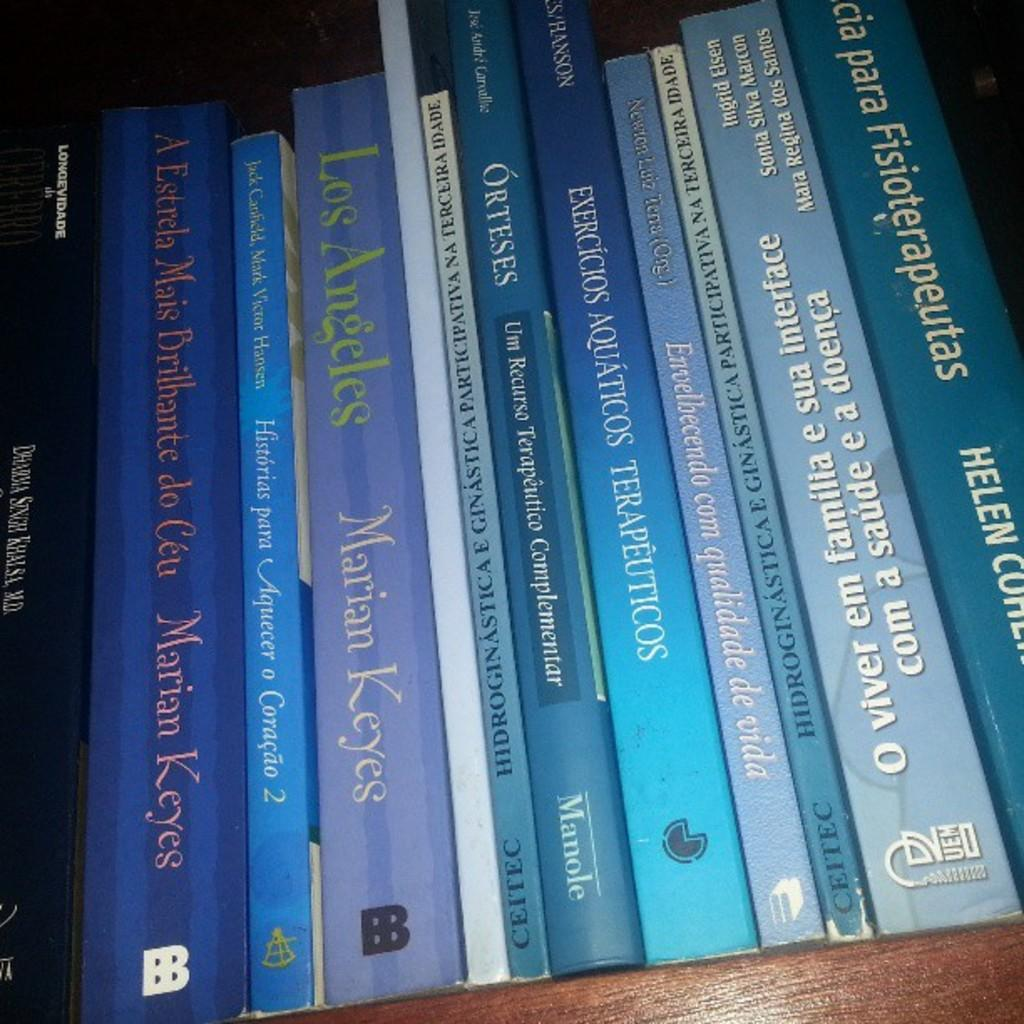Provide a one-sentence caption for the provided image. A stack of books, most of which were written by Marian Keyes. 